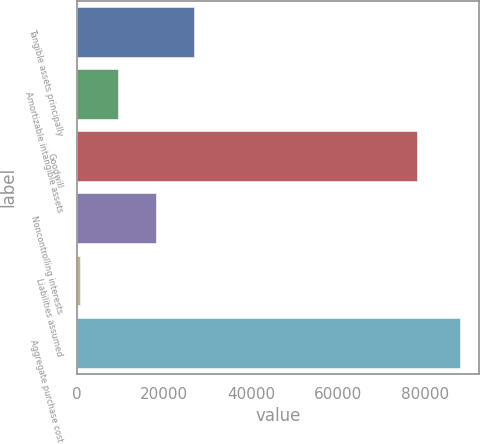<chart> <loc_0><loc_0><loc_500><loc_500><bar_chart><fcel>Tangible assets principally<fcel>Amortizable intangible assets<fcel>Goodwill<fcel>Noncontrolling interests<fcel>Liabilities assumed<fcel>Aggregate purchase cost<nl><fcel>26750.5<fcel>9263.5<fcel>78199<fcel>18007<fcel>520<fcel>87955<nl></chart> 